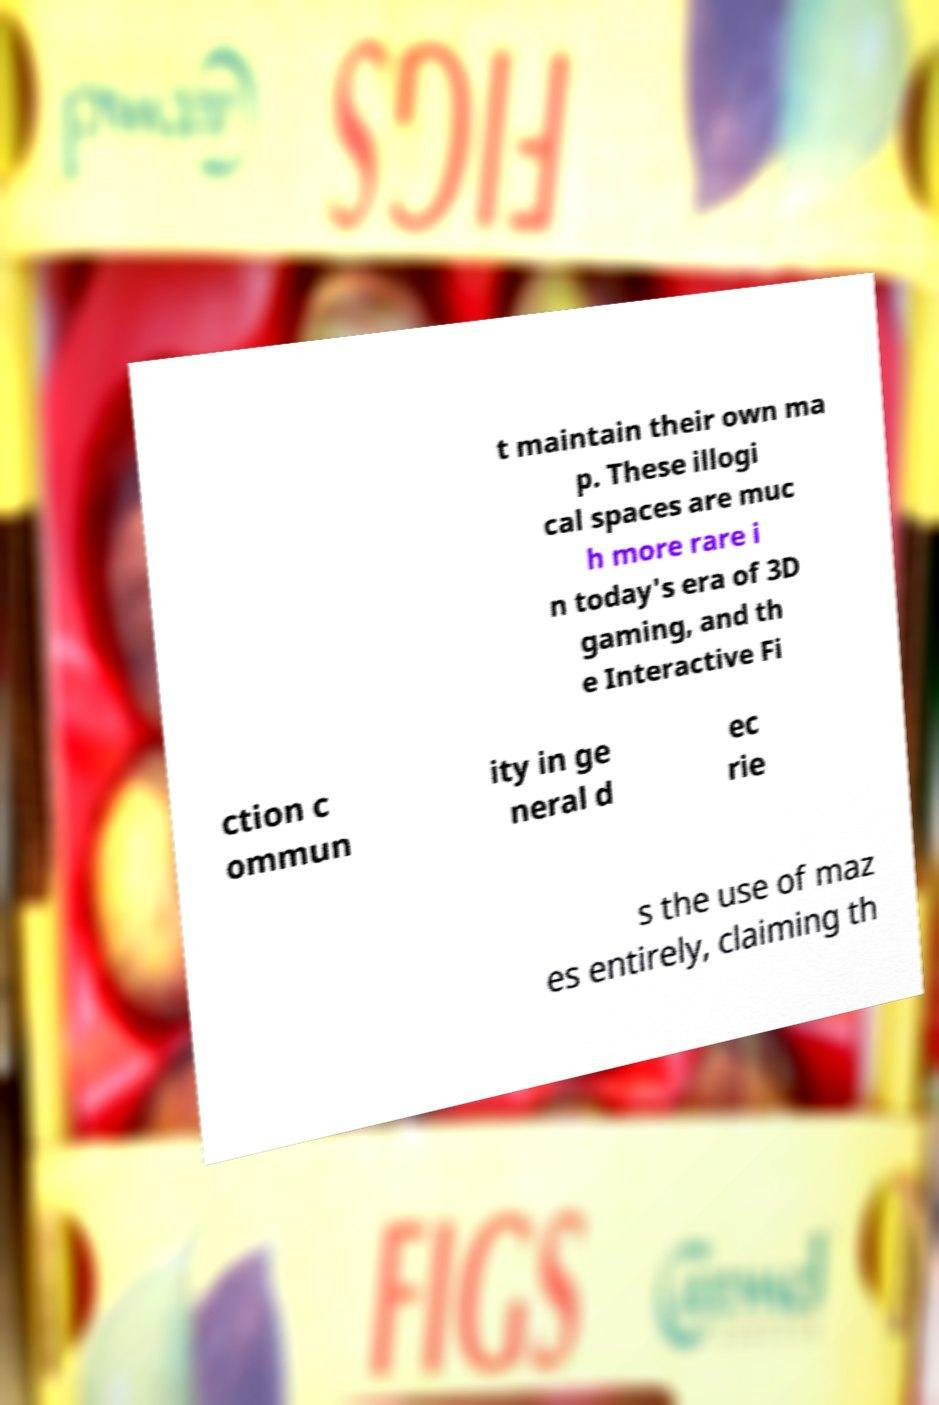There's text embedded in this image that I need extracted. Can you transcribe it verbatim? t maintain their own ma p. These illogi cal spaces are muc h more rare i n today's era of 3D gaming, and th e Interactive Fi ction c ommun ity in ge neral d ec rie s the use of maz es entirely, claiming th 